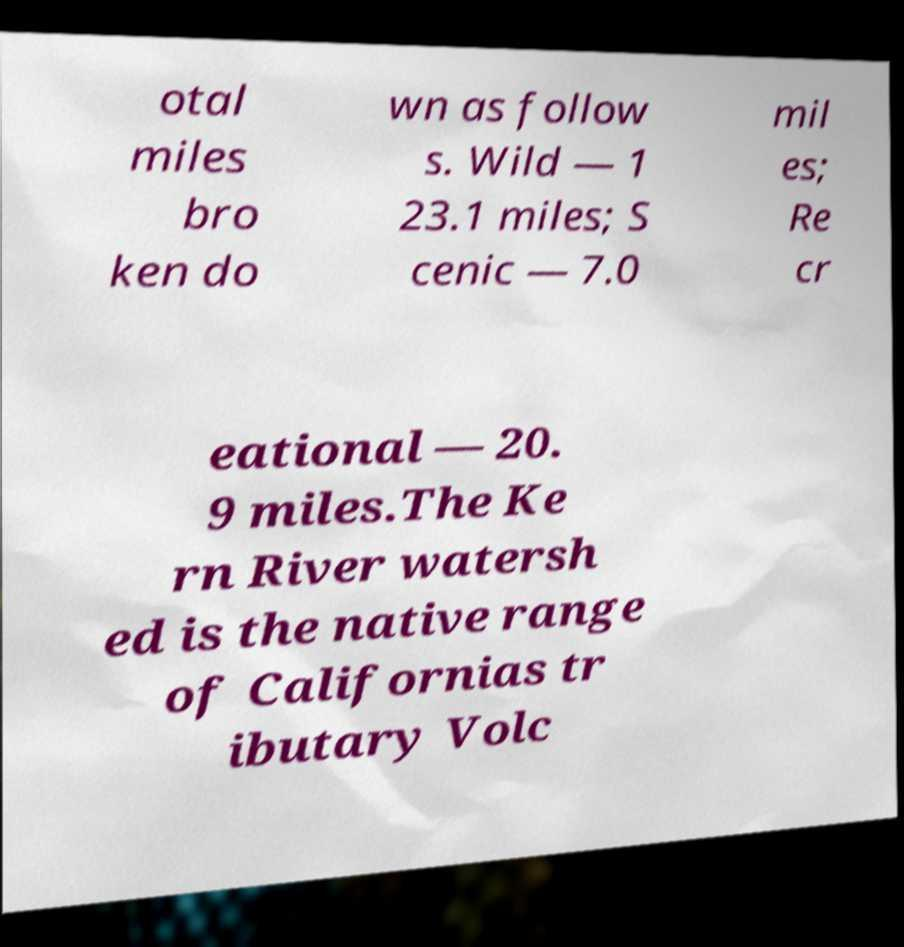Can you accurately transcribe the text from the provided image for me? otal miles bro ken do wn as follow s. Wild — 1 23.1 miles; S cenic — 7.0 mil es; Re cr eational — 20. 9 miles.The Ke rn River watersh ed is the native range of Californias tr ibutary Volc 